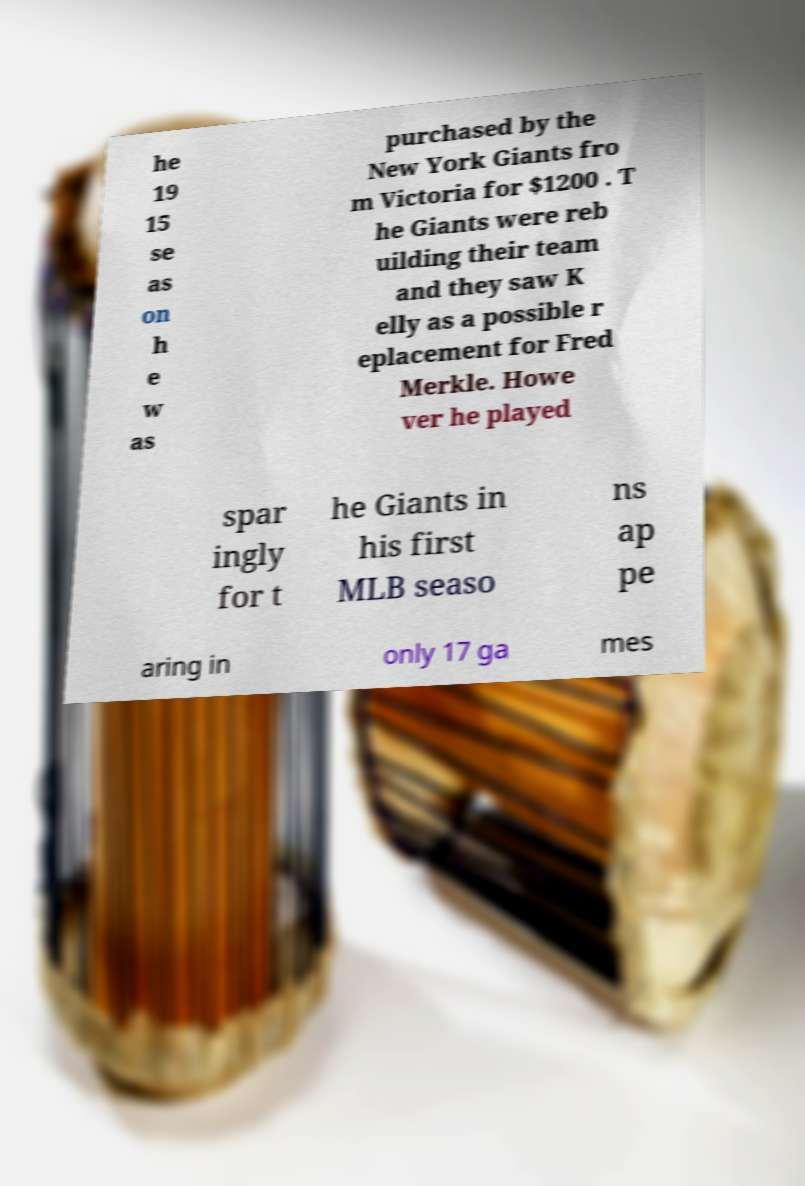Please identify and transcribe the text found in this image. he 19 15 se as on h e w as purchased by the New York Giants fro m Victoria for $1200 . T he Giants were reb uilding their team and they saw K elly as a possible r eplacement for Fred Merkle. Howe ver he played spar ingly for t he Giants in his first MLB seaso ns ap pe aring in only 17 ga mes 